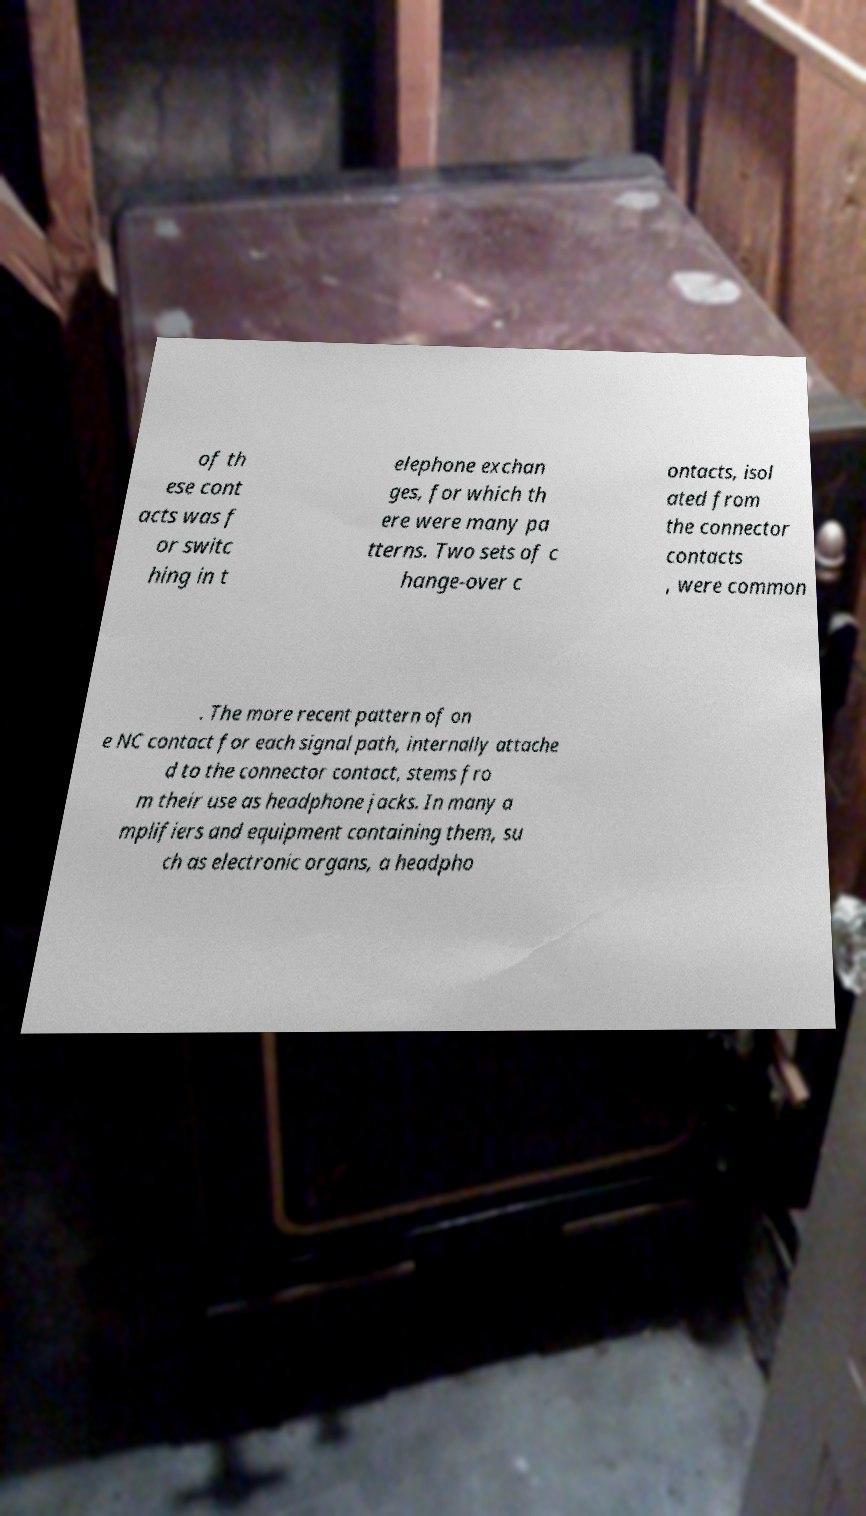Please read and relay the text visible in this image. What does it say? of th ese cont acts was f or switc hing in t elephone exchan ges, for which th ere were many pa tterns. Two sets of c hange-over c ontacts, isol ated from the connector contacts , were common . The more recent pattern of on e NC contact for each signal path, internally attache d to the connector contact, stems fro m their use as headphone jacks. In many a mplifiers and equipment containing them, su ch as electronic organs, a headpho 